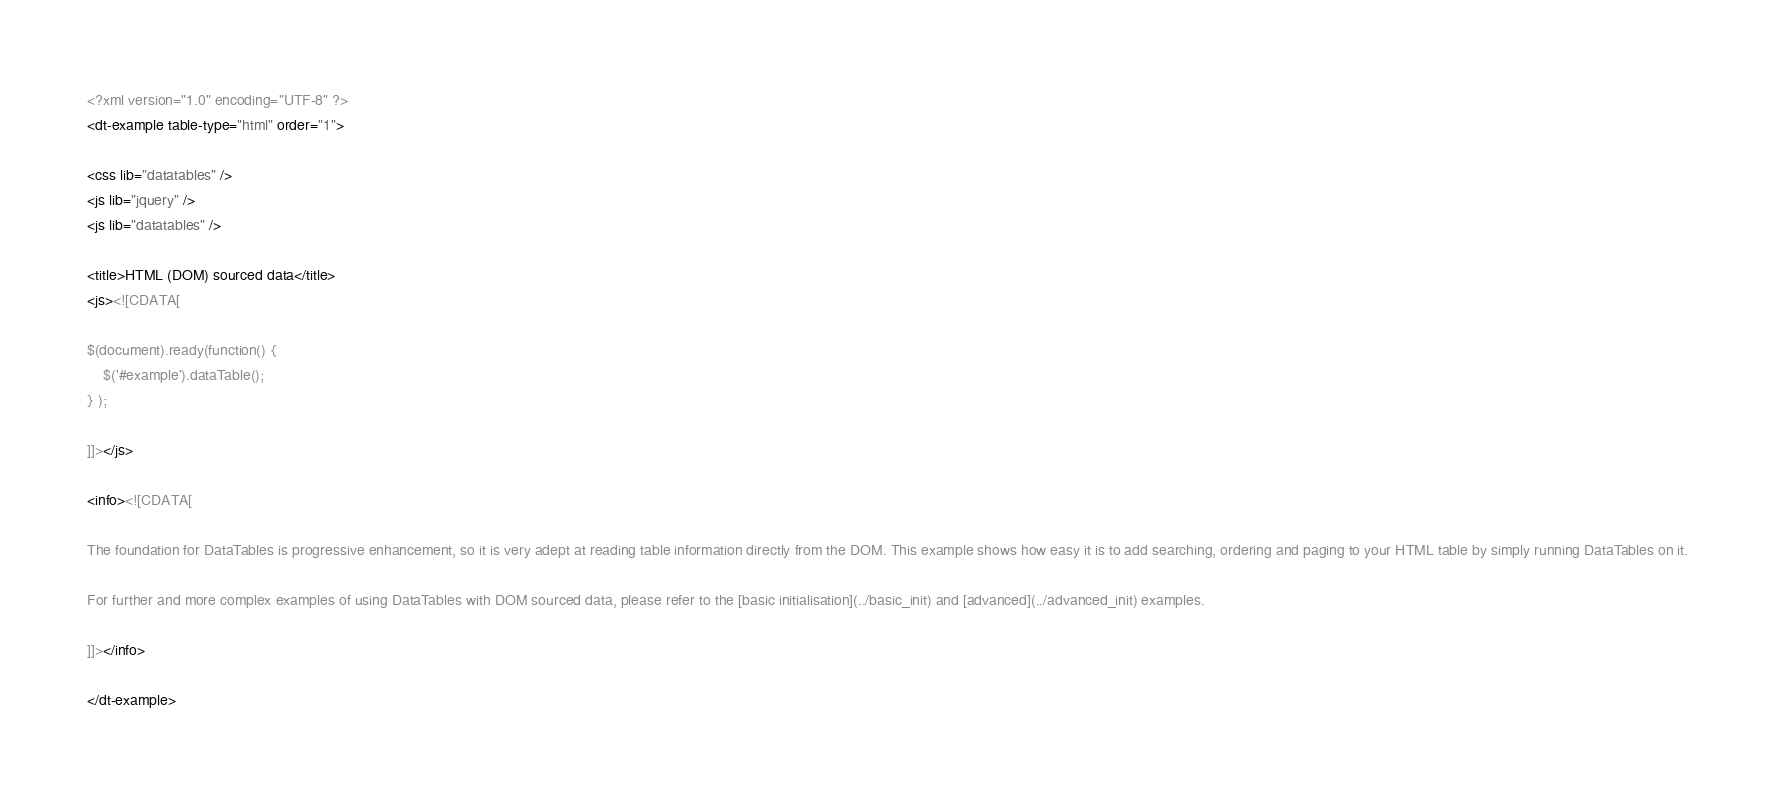<code> <loc_0><loc_0><loc_500><loc_500><_XML_><?xml version="1.0" encoding="UTF-8" ?>
<dt-example table-type="html" order="1">

<css lib="datatables" />
<js lib="jquery" />
<js lib="datatables" />

<title>HTML (DOM) sourced data</title>
<js><![CDATA[

$(document).ready(function() {
	$('#example').dataTable();
} );

]]></js>

<info><![CDATA[

The foundation for DataTables is progressive enhancement, so it is very adept at reading table information directly from the DOM. This example shows how easy it is to add searching, ordering and paging to your HTML table by simply running DataTables on it.

For further and more complex examples of using DataTables with DOM sourced data, please refer to the [basic initialisation](../basic_init) and [advanced](../advanced_init) examples.

]]></info>

</dt-example>
</code> 